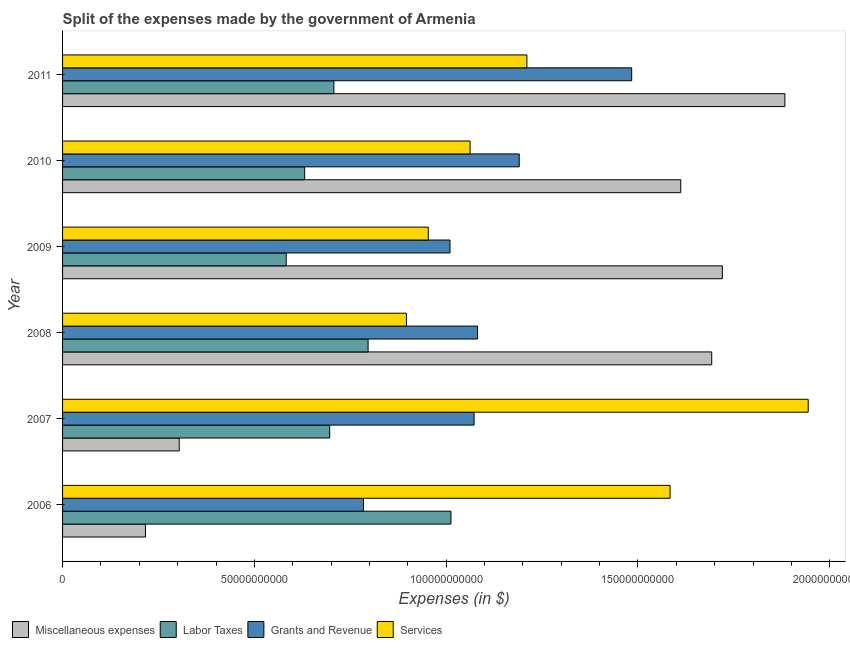Are the number of bars per tick equal to the number of legend labels?
Your answer should be very brief. Yes. How many bars are there on the 5th tick from the top?
Ensure brevity in your answer.  4. How many bars are there on the 1st tick from the bottom?
Ensure brevity in your answer.  4. In how many cases, is the number of bars for a given year not equal to the number of legend labels?
Make the answer very short. 0. What is the amount spent on labor taxes in 2008?
Your response must be concise. 7.97e+1. Across all years, what is the maximum amount spent on labor taxes?
Keep it short and to the point. 1.01e+11. Across all years, what is the minimum amount spent on labor taxes?
Your answer should be very brief. 5.83e+1. In which year was the amount spent on grants and revenue maximum?
Your response must be concise. 2011. In which year was the amount spent on grants and revenue minimum?
Offer a very short reply. 2006. What is the total amount spent on labor taxes in the graph?
Your answer should be compact. 4.43e+11. What is the difference between the amount spent on labor taxes in 2006 and that in 2009?
Ensure brevity in your answer.  4.30e+1. What is the difference between the amount spent on services in 2007 and the amount spent on grants and revenue in 2008?
Make the answer very short. 8.62e+1. What is the average amount spent on grants and revenue per year?
Provide a succinct answer. 1.10e+11. In the year 2007, what is the difference between the amount spent on labor taxes and amount spent on services?
Provide a short and direct response. -1.25e+11. In how many years, is the amount spent on labor taxes greater than 170000000000 $?
Give a very brief answer. 0. What is the ratio of the amount spent on grants and revenue in 2008 to that in 2009?
Keep it short and to the point. 1.07. What is the difference between the highest and the second highest amount spent on services?
Your answer should be very brief. 3.60e+1. What is the difference between the highest and the lowest amount spent on miscellaneous expenses?
Your answer should be very brief. 1.67e+11. In how many years, is the amount spent on labor taxes greater than the average amount spent on labor taxes taken over all years?
Give a very brief answer. 2. Is the sum of the amount spent on miscellaneous expenses in 2007 and 2010 greater than the maximum amount spent on labor taxes across all years?
Your answer should be compact. Yes. What does the 2nd bar from the top in 2007 represents?
Make the answer very short. Grants and Revenue. What does the 4th bar from the bottom in 2007 represents?
Keep it short and to the point. Services. Is it the case that in every year, the sum of the amount spent on miscellaneous expenses and amount spent on labor taxes is greater than the amount spent on grants and revenue?
Offer a very short reply. No. How many bars are there?
Provide a succinct answer. 24. Are all the bars in the graph horizontal?
Make the answer very short. Yes. How many years are there in the graph?
Your answer should be compact. 6. What is the difference between two consecutive major ticks on the X-axis?
Ensure brevity in your answer.  5.00e+1. Are the values on the major ticks of X-axis written in scientific E-notation?
Your answer should be very brief. No. Does the graph contain any zero values?
Your response must be concise. No. Does the graph contain grids?
Provide a short and direct response. No. Where does the legend appear in the graph?
Your response must be concise. Bottom left. How many legend labels are there?
Ensure brevity in your answer.  4. How are the legend labels stacked?
Provide a short and direct response. Horizontal. What is the title of the graph?
Keep it short and to the point. Split of the expenses made by the government of Armenia. What is the label or title of the X-axis?
Make the answer very short. Expenses (in $). What is the Expenses (in $) in Miscellaneous expenses in 2006?
Provide a short and direct response. 2.16e+1. What is the Expenses (in $) in Labor Taxes in 2006?
Your answer should be compact. 1.01e+11. What is the Expenses (in $) of Grants and Revenue in 2006?
Your response must be concise. 7.84e+1. What is the Expenses (in $) of Services in 2006?
Offer a terse response. 1.58e+11. What is the Expenses (in $) in Miscellaneous expenses in 2007?
Make the answer very short. 3.04e+1. What is the Expenses (in $) in Labor Taxes in 2007?
Your response must be concise. 6.96e+1. What is the Expenses (in $) of Grants and Revenue in 2007?
Offer a very short reply. 1.07e+11. What is the Expenses (in $) in Services in 2007?
Offer a very short reply. 1.94e+11. What is the Expenses (in $) of Miscellaneous expenses in 2008?
Your response must be concise. 1.69e+11. What is the Expenses (in $) of Labor Taxes in 2008?
Ensure brevity in your answer.  7.97e+1. What is the Expenses (in $) in Grants and Revenue in 2008?
Your answer should be compact. 1.08e+11. What is the Expenses (in $) of Services in 2008?
Provide a short and direct response. 8.96e+1. What is the Expenses (in $) in Miscellaneous expenses in 2009?
Offer a very short reply. 1.72e+11. What is the Expenses (in $) of Labor Taxes in 2009?
Your answer should be compact. 5.83e+1. What is the Expenses (in $) in Grants and Revenue in 2009?
Your answer should be compact. 1.01e+11. What is the Expenses (in $) in Services in 2009?
Give a very brief answer. 9.53e+1. What is the Expenses (in $) of Miscellaneous expenses in 2010?
Offer a terse response. 1.61e+11. What is the Expenses (in $) in Labor Taxes in 2010?
Your answer should be very brief. 6.31e+1. What is the Expenses (in $) of Grants and Revenue in 2010?
Your answer should be compact. 1.19e+11. What is the Expenses (in $) in Services in 2010?
Ensure brevity in your answer.  1.06e+11. What is the Expenses (in $) of Miscellaneous expenses in 2011?
Keep it short and to the point. 1.88e+11. What is the Expenses (in $) in Labor Taxes in 2011?
Your answer should be compact. 7.07e+1. What is the Expenses (in $) of Grants and Revenue in 2011?
Keep it short and to the point. 1.48e+11. What is the Expenses (in $) in Services in 2011?
Make the answer very short. 1.21e+11. Across all years, what is the maximum Expenses (in $) of Miscellaneous expenses?
Offer a very short reply. 1.88e+11. Across all years, what is the maximum Expenses (in $) in Labor Taxes?
Offer a very short reply. 1.01e+11. Across all years, what is the maximum Expenses (in $) of Grants and Revenue?
Provide a short and direct response. 1.48e+11. Across all years, what is the maximum Expenses (in $) in Services?
Give a very brief answer. 1.94e+11. Across all years, what is the minimum Expenses (in $) of Miscellaneous expenses?
Your answer should be very brief. 2.16e+1. Across all years, what is the minimum Expenses (in $) in Labor Taxes?
Ensure brevity in your answer.  5.83e+1. Across all years, what is the minimum Expenses (in $) of Grants and Revenue?
Your response must be concise. 7.84e+1. Across all years, what is the minimum Expenses (in $) of Services?
Offer a terse response. 8.96e+1. What is the total Expenses (in $) in Miscellaneous expenses in the graph?
Your answer should be compact. 7.43e+11. What is the total Expenses (in $) of Labor Taxes in the graph?
Your answer should be compact. 4.43e+11. What is the total Expenses (in $) in Grants and Revenue in the graph?
Give a very brief answer. 6.62e+11. What is the total Expenses (in $) in Services in the graph?
Offer a very short reply. 7.65e+11. What is the difference between the Expenses (in $) of Miscellaneous expenses in 2006 and that in 2007?
Your answer should be very brief. -8.79e+09. What is the difference between the Expenses (in $) in Labor Taxes in 2006 and that in 2007?
Offer a terse response. 3.16e+1. What is the difference between the Expenses (in $) in Grants and Revenue in 2006 and that in 2007?
Ensure brevity in your answer.  -2.89e+1. What is the difference between the Expenses (in $) in Services in 2006 and that in 2007?
Provide a succinct answer. -3.60e+1. What is the difference between the Expenses (in $) of Miscellaneous expenses in 2006 and that in 2008?
Your answer should be very brief. -1.48e+11. What is the difference between the Expenses (in $) of Labor Taxes in 2006 and that in 2008?
Give a very brief answer. 2.16e+1. What is the difference between the Expenses (in $) in Grants and Revenue in 2006 and that in 2008?
Provide a short and direct response. -2.98e+1. What is the difference between the Expenses (in $) in Services in 2006 and that in 2008?
Your response must be concise. 6.87e+1. What is the difference between the Expenses (in $) of Miscellaneous expenses in 2006 and that in 2009?
Your answer should be very brief. -1.50e+11. What is the difference between the Expenses (in $) of Labor Taxes in 2006 and that in 2009?
Your response must be concise. 4.30e+1. What is the difference between the Expenses (in $) of Grants and Revenue in 2006 and that in 2009?
Provide a succinct answer. -2.26e+1. What is the difference between the Expenses (in $) of Services in 2006 and that in 2009?
Make the answer very short. 6.30e+1. What is the difference between the Expenses (in $) in Miscellaneous expenses in 2006 and that in 2010?
Ensure brevity in your answer.  -1.40e+11. What is the difference between the Expenses (in $) in Labor Taxes in 2006 and that in 2010?
Keep it short and to the point. 3.81e+1. What is the difference between the Expenses (in $) of Grants and Revenue in 2006 and that in 2010?
Give a very brief answer. -4.06e+1. What is the difference between the Expenses (in $) in Services in 2006 and that in 2010?
Your answer should be compact. 5.21e+1. What is the difference between the Expenses (in $) of Miscellaneous expenses in 2006 and that in 2011?
Offer a terse response. -1.67e+11. What is the difference between the Expenses (in $) in Labor Taxes in 2006 and that in 2011?
Offer a very short reply. 3.05e+1. What is the difference between the Expenses (in $) of Grants and Revenue in 2006 and that in 2011?
Make the answer very short. -6.99e+1. What is the difference between the Expenses (in $) of Services in 2006 and that in 2011?
Your answer should be very brief. 3.73e+1. What is the difference between the Expenses (in $) of Miscellaneous expenses in 2007 and that in 2008?
Your answer should be very brief. -1.39e+11. What is the difference between the Expenses (in $) in Labor Taxes in 2007 and that in 2008?
Offer a very short reply. -1.00e+1. What is the difference between the Expenses (in $) of Grants and Revenue in 2007 and that in 2008?
Keep it short and to the point. -8.98e+08. What is the difference between the Expenses (in $) of Services in 2007 and that in 2008?
Offer a terse response. 1.05e+11. What is the difference between the Expenses (in $) in Miscellaneous expenses in 2007 and that in 2009?
Make the answer very short. -1.42e+11. What is the difference between the Expenses (in $) of Labor Taxes in 2007 and that in 2009?
Ensure brevity in your answer.  1.13e+1. What is the difference between the Expenses (in $) of Grants and Revenue in 2007 and that in 2009?
Offer a terse response. 6.28e+09. What is the difference between the Expenses (in $) in Services in 2007 and that in 2009?
Offer a very short reply. 9.90e+1. What is the difference between the Expenses (in $) in Miscellaneous expenses in 2007 and that in 2010?
Offer a terse response. -1.31e+11. What is the difference between the Expenses (in $) in Labor Taxes in 2007 and that in 2010?
Offer a terse response. 6.53e+09. What is the difference between the Expenses (in $) of Grants and Revenue in 2007 and that in 2010?
Your answer should be very brief. -1.18e+1. What is the difference between the Expenses (in $) of Services in 2007 and that in 2010?
Keep it short and to the point. 8.82e+1. What is the difference between the Expenses (in $) of Miscellaneous expenses in 2007 and that in 2011?
Give a very brief answer. -1.58e+11. What is the difference between the Expenses (in $) in Labor Taxes in 2007 and that in 2011?
Your answer should be compact. -1.09e+09. What is the difference between the Expenses (in $) of Grants and Revenue in 2007 and that in 2011?
Your answer should be compact. -4.11e+1. What is the difference between the Expenses (in $) of Services in 2007 and that in 2011?
Provide a succinct answer. 7.33e+1. What is the difference between the Expenses (in $) of Miscellaneous expenses in 2008 and that in 2009?
Provide a succinct answer. -2.76e+09. What is the difference between the Expenses (in $) of Labor Taxes in 2008 and that in 2009?
Your answer should be very brief. 2.14e+1. What is the difference between the Expenses (in $) in Grants and Revenue in 2008 and that in 2009?
Offer a very short reply. 7.18e+09. What is the difference between the Expenses (in $) in Services in 2008 and that in 2009?
Make the answer very short. -5.71e+09. What is the difference between the Expenses (in $) of Miscellaneous expenses in 2008 and that in 2010?
Provide a short and direct response. 8.07e+09. What is the difference between the Expenses (in $) of Labor Taxes in 2008 and that in 2010?
Ensure brevity in your answer.  1.65e+1. What is the difference between the Expenses (in $) of Grants and Revenue in 2008 and that in 2010?
Your response must be concise. -1.09e+1. What is the difference between the Expenses (in $) of Services in 2008 and that in 2010?
Provide a succinct answer. -1.66e+1. What is the difference between the Expenses (in $) in Miscellaneous expenses in 2008 and that in 2011?
Ensure brevity in your answer.  -1.91e+1. What is the difference between the Expenses (in $) in Labor Taxes in 2008 and that in 2011?
Provide a short and direct response. 8.92e+09. What is the difference between the Expenses (in $) in Grants and Revenue in 2008 and that in 2011?
Provide a short and direct response. -4.02e+1. What is the difference between the Expenses (in $) of Services in 2008 and that in 2011?
Provide a short and direct response. -3.14e+1. What is the difference between the Expenses (in $) in Miscellaneous expenses in 2009 and that in 2010?
Provide a succinct answer. 1.08e+1. What is the difference between the Expenses (in $) of Labor Taxes in 2009 and that in 2010?
Make the answer very short. -4.82e+09. What is the difference between the Expenses (in $) of Grants and Revenue in 2009 and that in 2010?
Provide a short and direct response. -1.80e+1. What is the difference between the Expenses (in $) in Services in 2009 and that in 2010?
Make the answer very short. -1.09e+1. What is the difference between the Expenses (in $) of Miscellaneous expenses in 2009 and that in 2011?
Give a very brief answer. -1.63e+1. What is the difference between the Expenses (in $) in Labor Taxes in 2009 and that in 2011?
Keep it short and to the point. -1.24e+1. What is the difference between the Expenses (in $) of Grants and Revenue in 2009 and that in 2011?
Provide a succinct answer. -4.74e+1. What is the difference between the Expenses (in $) in Services in 2009 and that in 2011?
Provide a short and direct response. -2.57e+1. What is the difference between the Expenses (in $) in Miscellaneous expenses in 2010 and that in 2011?
Make the answer very short. -2.71e+1. What is the difference between the Expenses (in $) in Labor Taxes in 2010 and that in 2011?
Ensure brevity in your answer.  -7.62e+09. What is the difference between the Expenses (in $) in Grants and Revenue in 2010 and that in 2011?
Keep it short and to the point. -2.93e+1. What is the difference between the Expenses (in $) in Services in 2010 and that in 2011?
Give a very brief answer. -1.48e+1. What is the difference between the Expenses (in $) of Miscellaneous expenses in 2006 and the Expenses (in $) of Labor Taxes in 2007?
Provide a short and direct response. -4.80e+1. What is the difference between the Expenses (in $) of Miscellaneous expenses in 2006 and the Expenses (in $) of Grants and Revenue in 2007?
Make the answer very short. -8.57e+1. What is the difference between the Expenses (in $) of Miscellaneous expenses in 2006 and the Expenses (in $) of Services in 2007?
Keep it short and to the point. -1.73e+11. What is the difference between the Expenses (in $) of Labor Taxes in 2006 and the Expenses (in $) of Grants and Revenue in 2007?
Give a very brief answer. -6.03e+09. What is the difference between the Expenses (in $) in Labor Taxes in 2006 and the Expenses (in $) in Services in 2007?
Your answer should be very brief. -9.31e+1. What is the difference between the Expenses (in $) in Grants and Revenue in 2006 and the Expenses (in $) in Services in 2007?
Offer a very short reply. -1.16e+11. What is the difference between the Expenses (in $) of Miscellaneous expenses in 2006 and the Expenses (in $) of Labor Taxes in 2008?
Offer a terse response. -5.80e+1. What is the difference between the Expenses (in $) of Miscellaneous expenses in 2006 and the Expenses (in $) of Grants and Revenue in 2008?
Ensure brevity in your answer.  -8.66e+1. What is the difference between the Expenses (in $) in Miscellaneous expenses in 2006 and the Expenses (in $) in Services in 2008?
Keep it short and to the point. -6.80e+1. What is the difference between the Expenses (in $) of Labor Taxes in 2006 and the Expenses (in $) of Grants and Revenue in 2008?
Offer a very short reply. -6.93e+09. What is the difference between the Expenses (in $) in Labor Taxes in 2006 and the Expenses (in $) in Services in 2008?
Ensure brevity in your answer.  1.16e+1. What is the difference between the Expenses (in $) of Grants and Revenue in 2006 and the Expenses (in $) of Services in 2008?
Give a very brief answer. -1.12e+1. What is the difference between the Expenses (in $) in Miscellaneous expenses in 2006 and the Expenses (in $) in Labor Taxes in 2009?
Your response must be concise. -3.67e+1. What is the difference between the Expenses (in $) of Miscellaneous expenses in 2006 and the Expenses (in $) of Grants and Revenue in 2009?
Offer a very short reply. -7.94e+1. What is the difference between the Expenses (in $) in Miscellaneous expenses in 2006 and the Expenses (in $) in Services in 2009?
Give a very brief answer. -7.37e+1. What is the difference between the Expenses (in $) of Labor Taxes in 2006 and the Expenses (in $) of Grants and Revenue in 2009?
Ensure brevity in your answer.  2.45e+08. What is the difference between the Expenses (in $) in Labor Taxes in 2006 and the Expenses (in $) in Services in 2009?
Make the answer very short. 5.90e+09. What is the difference between the Expenses (in $) of Grants and Revenue in 2006 and the Expenses (in $) of Services in 2009?
Your response must be concise. -1.69e+1. What is the difference between the Expenses (in $) of Miscellaneous expenses in 2006 and the Expenses (in $) of Labor Taxes in 2010?
Provide a succinct answer. -4.15e+1. What is the difference between the Expenses (in $) in Miscellaneous expenses in 2006 and the Expenses (in $) in Grants and Revenue in 2010?
Give a very brief answer. -9.74e+1. What is the difference between the Expenses (in $) of Miscellaneous expenses in 2006 and the Expenses (in $) of Services in 2010?
Keep it short and to the point. -8.46e+1. What is the difference between the Expenses (in $) in Labor Taxes in 2006 and the Expenses (in $) in Grants and Revenue in 2010?
Your answer should be compact. -1.78e+1. What is the difference between the Expenses (in $) of Labor Taxes in 2006 and the Expenses (in $) of Services in 2010?
Give a very brief answer. -4.99e+09. What is the difference between the Expenses (in $) of Grants and Revenue in 2006 and the Expenses (in $) of Services in 2010?
Your answer should be compact. -2.78e+1. What is the difference between the Expenses (in $) in Miscellaneous expenses in 2006 and the Expenses (in $) in Labor Taxes in 2011?
Make the answer very short. -4.91e+1. What is the difference between the Expenses (in $) of Miscellaneous expenses in 2006 and the Expenses (in $) of Grants and Revenue in 2011?
Your answer should be very brief. -1.27e+11. What is the difference between the Expenses (in $) of Miscellaneous expenses in 2006 and the Expenses (in $) of Services in 2011?
Offer a very short reply. -9.94e+1. What is the difference between the Expenses (in $) in Labor Taxes in 2006 and the Expenses (in $) in Grants and Revenue in 2011?
Give a very brief answer. -4.71e+1. What is the difference between the Expenses (in $) of Labor Taxes in 2006 and the Expenses (in $) of Services in 2011?
Give a very brief answer. -1.98e+1. What is the difference between the Expenses (in $) in Grants and Revenue in 2006 and the Expenses (in $) in Services in 2011?
Ensure brevity in your answer.  -4.26e+1. What is the difference between the Expenses (in $) of Miscellaneous expenses in 2007 and the Expenses (in $) of Labor Taxes in 2008?
Provide a short and direct response. -4.92e+1. What is the difference between the Expenses (in $) in Miscellaneous expenses in 2007 and the Expenses (in $) in Grants and Revenue in 2008?
Your answer should be very brief. -7.78e+1. What is the difference between the Expenses (in $) of Miscellaneous expenses in 2007 and the Expenses (in $) of Services in 2008?
Your answer should be compact. -5.92e+1. What is the difference between the Expenses (in $) in Labor Taxes in 2007 and the Expenses (in $) in Grants and Revenue in 2008?
Your response must be concise. -3.85e+1. What is the difference between the Expenses (in $) in Labor Taxes in 2007 and the Expenses (in $) in Services in 2008?
Your answer should be very brief. -2.00e+1. What is the difference between the Expenses (in $) of Grants and Revenue in 2007 and the Expenses (in $) of Services in 2008?
Make the answer very short. 1.76e+1. What is the difference between the Expenses (in $) of Miscellaneous expenses in 2007 and the Expenses (in $) of Labor Taxes in 2009?
Offer a very short reply. -2.79e+1. What is the difference between the Expenses (in $) of Miscellaneous expenses in 2007 and the Expenses (in $) of Grants and Revenue in 2009?
Offer a terse response. -7.06e+1. What is the difference between the Expenses (in $) in Miscellaneous expenses in 2007 and the Expenses (in $) in Services in 2009?
Provide a succinct answer. -6.49e+1. What is the difference between the Expenses (in $) in Labor Taxes in 2007 and the Expenses (in $) in Grants and Revenue in 2009?
Offer a very short reply. -3.14e+1. What is the difference between the Expenses (in $) in Labor Taxes in 2007 and the Expenses (in $) in Services in 2009?
Offer a terse response. -2.57e+1. What is the difference between the Expenses (in $) of Grants and Revenue in 2007 and the Expenses (in $) of Services in 2009?
Provide a succinct answer. 1.19e+1. What is the difference between the Expenses (in $) of Miscellaneous expenses in 2007 and the Expenses (in $) of Labor Taxes in 2010?
Provide a short and direct response. -3.27e+1. What is the difference between the Expenses (in $) of Miscellaneous expenses in 2007 and the Expenses (in $) of Grants and Revenue in 2010?
Give a very brief answer. -8.87e+1. What is the difference between the Expenses (in $) in Miscellaneous expenses in 2007 and the Expenses (in $) in Services in 2010?
Provide a short and direct response. -7.58e+1. What is the difference between the Expenses (in $) of Labor Taxes in 2007 and the Expenses (in $) of Grants and Revenue in 2010?
Make the answer very short. -4.94e+1. What is the difference between the Expenses (in $) of Labor Taxes in 2007 and the Expenses (in $) of Services in 2010?
Ensure brevity in your answer.  -3.66e+1. What is the difference between the Expenses (in $) in Grants and Revenue in 2007 and the Expenses (in $) in Services in 2010?
Ensure brevity in your answer.  1.05e+09. What is the difference between the Expenses (in $) in Miscellaneous expenses in 2007 and the Expenses (in $) in Labor Taxes in 2011?
Ensure brevity in your answer.  -4.03e+1. What is the difference between the Expenses (in $) in Miscellaneous expenses in 2007 and the Expenses (in $) in Grants and Revenue in 2011?
Your answer should be compact. -1.18e+11. What is the difference between the Expenses (in $) of Miscellaneous expenses in 2007 and the Expenses (in $) of Services in 2011?
Ensure brevity in your answer.  -9.06e+1. What is the difference between the Expenses (in $) of Labor Taxes in 2007 and the Expenses (in $) of Grants and Revenue in 2011?
Give a very brief answer. -7.87e+1. What is the difference between the Expenses (in $) in Labor Taxes in 2007 and the Expenses (in $) in Services in 2011?
Offer a very short reply. -5.14e+1. What is the difference between the Expenses (in $) of Grants and Revenue in 2007 and the Expenses (in $) of Services in 2011?
Provide a short and direct response. -1.38e+1. What is the difference between the Expenses (in $) of Miscellaneous expenses in 2008 and the Expenses (in $) of Labor Taxes in 2009?
Provide a succinct answer. 1.11e+11. What is the difference between the Expenses (in $) in Miscellaneous expenses in 2008 and the Expenses (in $) in Grants and Revenue in 2009?
Keep it short and to the point. 6.82e+1. What is the difference between the Expenses (in $) in Miscellaneous expenses in 2008 and the Expenses (in $) in Services in 2009?
Your answer should be compact. 7.39e+1. What is the difference between the Expenses (in $) in Labor Taxes in 2008 and the Expenses (in $) in Grants and Revenue in 2009?
Offer a terse response. -2.14e+1. What is the difference between the Expenses (in $) of Labor Taxes in 2008 and the Expenses (in $) of Services in 2009?
Keep it short and to the point. -1.57e+1. What is the difference between the Expenses (in $) in Grants and Revenue in 2008 and the Expenses (in $) in Services in 2009?
Your response must be concise. 1.28e+1. What is the difference between the Expenses (in $) in Miscellaneous expenses in 2008 and the Expenses (in $) in Labor Taxes in 2010?
Offer a terse response. 1.06e+11. What is the difference between the Expenses (in $) of Miscellaneous expenses in 2008 and the Expenses (in $) of Grants and Revenue in 2010?
Ensure brevity in your answer.  5.02e+1. What is the difference between the Expenses (in $) of Miscellaneous expenses in 2008 and the Expenses (in $) of Services in 2010?
Provide a short and direct response. 6.30e+1. What is the difference between the Expenses (in $) of Labor Taxes in 2008 and the Expenses (in $) of Grants and Revenue in 2010?
Your answer should be very brief. -3.94e+1. What is the difference between the Expenses (in $) of Labor Taxes in 2008 and the Expenses (in $) of Services in 2010?
Give a very brief answer. -2.66e+1. What is the difference between the Expenses (in $) in Grants and Revenue in 2008 and the Expenses (in $) in Services in 2010?
Your response must be concise. 1.94e+09. What is the difference between the Expenses (in $) in Miscellaneous expenses in 2008 and the Expenses (in $) in Labor Taxes in 2011?
Your answer should be very brief. 9.85e+1. What is the difference between the Expenses (in $) of Miscellaneous expenses in 2008 and the Expenses (in $) of Grants and Revenue in 2011?
Keep it short and to the point. 2.09e+1. What is the difference between the Expenses (in $) of Miscellaneous expenses in 2008 and the Expenses (in $) of Services in 2011?
Offer a very short reply. 4.82e+1. What is the difference between the Expenses (in $) of Labor Taxes in 2008 and the Expenses (in $) of Grants and Revenue in 2011?
Your answer should be very brief. -6.87e+1. What is the difference between the Expenses (in $) in Labor Taxes in 2008 and the Expenses (in $) in Services in 2011?
Your answer should be compact. -4.14e+1. What is the difference between the Expenses (in $) of Grants and Revenue in 2008 and the Expenses (in $) of Services in 2011?
Make the answer very short. -1.29e+1. What is the difference between the Expenses (in $) in Miscellaneous expenses in 2009 and the Expenses (in $) in Labor Taxes in 2010?
Make the answer very short. 1.09e+11. What is the difference between the Expenses (in $) of Miscellaneous expenses in 2009 and the Expenses (in $) of Grants and Revenue in 2010?
Keep it short and to the point. 5.29e+1. What is the difference between the Expenses (in $) in Miscellaneous expenses in 2009 and the Expenses (in $) in Services in 2010?
Provide a short and direct response. 6.58e+1. What is the difference between the Expenses (in $) in Labor Taxes in 2009 and the Expenses (in $) in Grants and Revenue in 2010?
Make the answer very short. -6.08e+1. What is the difference between the Expenses (in $) of Labor Taxes in 2009 and the Expenses (in $) of Services in 2010?
Keep it short and to the point. -4.79e+1. What is the difference between the Expenses (in $) in Grants and Revenue in 2009 and the Expenses (in $) in Services in 2010?
Give a very brief answer. -5.23e+09. What is the difference between the Expenses (in $) in Miscellaneous expenses in 2009 and the Expenses (in $) in Labor Taxes in 2011?
Provide a succinct answer. 1.01e+11. What is the difference between the Expenses (in $) in Miscellaneous expenses in 2009 and the Expenses (in $) in Grants and Revenue in 2011?
Offer a terse response. 2.36e+1. What is the difference between the Expenses (in $) of Miscellaneous expenses in 2009 and the Expenses (in $) of Services in 2011?
Your answer should be compact. 5.09e+1. What is the difference between the Expenses (in $) in Labor Taxes in 2009 and the Expenses (in $) in Grants and Revenue in 2011?
Offer a very short reply. -9.01e+1. What is the difference between the Expenses (in $) of Labor Taxes in 2009 and the Expenses (in $) of Services in 2011?
Your response must be concise. -6.28e+1. What is the difference between the Expenses (in $) in Grants and Revenue in 2009 and the Expenses (in $) in Services in 2011?
Offer a terse response. -2.00e+1. What is the difference between the Expenses (in $) in Miscellaneous expenses in 2010 and the Expenses (in $) in Labor Taxes in 2011?
Keep it short and to the point. 9.04e+1. What is the difference between the Expenses (in $) of Miscellaneous expenses in 2010 and the Expenses (in $) of Grants and Revenue in 2011?
Your answer should be very brief. 1.28e+1. What is the difference between the Expenses (in $) in Miscellaneous expenses in 2010 and the Expenses (in $) in Services in 2011?
Give a very brief answer. 4.01e+1. What is the difference between the Expenses (in $) of Labor Taxes in 2010 and the Expenses (in $) of Grants and Revenue in 2011?
Provide a short and direct response. -8.53e+1. What is the difference between the Expenses (in $) of Labor Taxes in 2010 and the Expenses (in $) of Services in 2011?
Provide a succinct answer. -5.79e+1. What is the difference between the Expenses (in $) in Grants and Revenue in 2010 and the Expenses (in $) in Services in 2011?
Your answer should be very brief. -2.00e+09. What is the average Expenses (in $) in Miscellaneous expenses per year?
Offer a terse response. 1.24e+11. What is the average Expenses (in $) in Labor Taxes per year?
Keep it short and to the point. 7.38e+1. What is the average Expenses (in $) in Grants and Revenue per year?
Provide a short and direct response. 1.10e+11. What is the average Expenses (in $) of Services per year?
Make the answer very short. 1.28e+11. In the year 2006, what is the difference between the Expenses (in $) in Miscellaneous expenses and Expenses (in $) in Labor Taxes?
Provide a succinct answer. -7.96e+1. In the year 2006, what is the difference between the Expenses (in $) in Miscellaneous expenses and Expenses (in $) in Grants and Revenue?
Keep it short and to the point. -5.68e+1. In the year 2006, what is the difference between the Expenses (in $) of Miscellaneous expenses and Expenses (in $) of Services?
Offer a very short reply. -1.37e+11. In the year 2006, what is the difference between the Expenses (in $) of Labor Taxes and Expenses (in $) of Grants and Revenue?
Keep it short and to the point. 2.28e+1. In the year 2006, what is the difference between the Expenses (in $) in Labor Taxes and Expenses (in $) in Services?
Offer a very short reply. -5.71e+1. In the year 2006, what is the difference between the Expenses (in $) of Grants and Revenue and Expenses (in $) of Services?
Make the answer very short. -8.00e+1. In the year 2007, what is the difference between the Expenses (in $) of Miscellaneous expenses and Expenses (in $) of Labor Taxes?
Offer a terse response. -3.92e+1. In the year 2007, what is the difference between the Expenses (in $) in Miscellaneous expenses and Expenses (in $) in Grants and Revenue?
Offer a very short reply. -7.69e+1. In the year 2007, what is the difference between the Expenses (in $) in Miscellaneous expenses and Expenses (in $) in Services?
Your answer should be very brief. -1.64e+11. In the year 2007, what is the difference between the Expenses (in $) of Labor Taxes and Expenses (in $) of Grants and Revenue?
Make the answer very short. -3.76e+1. In the year 2007, what is the difference between the Expenses (in $) in Labor Taxes and Expenses (in $) in Services?
Provide a short and direct response. -1.25e+11. In the year 2007, what is the difference between the Expenses (in $) in Grants and Revenue and Expenses (in $) in Services?
Give a very brief answer. -8.71e+1. In the year 2008, what is the difference between the Expenses (in $) in Miscellaneous expenses and Expenses (in $) in Labor Taxes?
Provide a succinct answer. 8.96e+1. In the year 2008, what is the difference between the Expenses (in $) in Miscellaneous expenses and Expenses (in $) in Grants and Revenue?
Provide a short and direct response. 6.11e+1. In the year 2008, what is the difference between the Expenses (in $) in Miscellaneous expenses and Expenses (in $) in Services?
Offer a terse response. 7.96e+1. In the year 2008, what is the difference between the Expenses (in $) of Labor Taxes and Expenses (in $) of Grants and Revenue?
Your answer should be compact. -2.85e+1. In the year 2008, what is the difference between the Expenses (in $) of Labor Taxes and Expenses (in $) of Services?
Ensure brevity in your answer.  -9.99e+09. In the year 2008, what is the difference between the Expenses (in $) of Grants and Revenue and Expenses (in $) of Services?
Your response must be concise. 1.85e+1. In the year 2009, what is the difference between the Expenses (in $) in Miscellaneous expenses and Expenses (in $) in Labor Taxes?
Offer a very short reply. 1.14e+11. In the year 2009, what is the difference between the Expenses (in $) of Miscellaneous expenses and Expenses (in $) of Grants and Revenue?
Make the answer very short. 7.10e+1. In the year 2009, what is the difference between the Expenses (in $) in Miscellaneous expenses and Expenses (in $) in Services?
Make the answer very short. 7.67e+1. In the year 2009, what is the difference between the Expenses (in $) of Labor Taxes and Expenses (in $) of Grants and Revenue?
Offer a terse response. -4.27e+1. In the year 2009, what is the difference between the Expenses (in $) in Labor Taxes and Expenses (in $) in Services?
Keep it short and to the point. -3.71e+1. In the year 2009, what is the difference between the Expenses (in $) of Grants and Revenue and Expenses (in $) of Services?
Your response must be concise. 5.66e+09. In the year 2010, what is the difference between the Expenses (in $) in Miscellaneous expenses and Expenses (in $) in Labor Taxes?
Your answer should be very brief. 9.81e+1. In the year 2010, what is the difference between the Expenses (in $) of Miscellaneous expenses and Expenses (in $) of Grants and Revenue?
Keep it short and to the point. 4.21e+1. In the year 2010, what is the difference between the Expenses (in $) in Miscellaneous expenses and Expenses (in $) in Services?
Provide a succinct answer. 5.49e+1. In the year 2010, what is the difference between the Expenses (in $) in Labor Taxes and Expenses (in $) in Grants and Revenue?
Ensure brevity in your answer.  -5.59e+1. In the year 2010, what is the difference between the Expenses (in $) of Labor Taxes and Expenses (in $) of Services?
Your response must be concise. -4.31e+1. In the year 2010, what is the difference between the Expenses (in $) of Grants and Revenue and Expenses (in $) of Services?
Give a very brief answer. 1.28e+1. In the year 2011, what is the difference between the Expenses (in $) of Miscellaneous expenses and Expenses (in $) of Labor Taxes?
Keep it short and to the point. 1.18e+11. In the year 2011, what is the difference between the Expenses (in $) in Miscellaneous expenses and Expenses (in $) in Grants and Revenue?
Keep it short and to the point. 3.99e+1. In the year 2011, what is the difference between the Expenses (in $) of Miscellaneous expenses and Expenses (in $) of Services?
Make the answer very short. 6.73e+1. In the year 2011, what is the difference between the Expenses (in $) in Labor Taxes and Expenses (in $) in Grants and Revenue?
Your answer should be compact. -7.76e+1. In the year 2011, what is the difference between the Expenses (in $) of Labor Taxes and Expenses (in $) of Services?
Your answer should be compact. -5.03e+1. In the year 2011, what is the difference between the Expenses (in $) of Grants and Revenue and Expenses (in $) of Services?
Ensure brevity in your answer.  2.73e+1. What is the ratio of the Expenses (in $) of Miscellaneous expenses in 2006 to that in 2007?
Your answer should be compact. 0.71. What is the ratio of the Expenses (in $) in Labor Taxes in 2006 to that in 2007?
Give a very brief answer. 1.45. What is the ratio of the Expenses (in $) in Grants and Revenue in 2006 to that in 2007?
Your answer should be compact. 0.73. What is the ratio of the Expenses (in $) in Services in 2006 to that in 2007?
Your answer should be very brief. 0.81. What is the ratio of the Expenses (in $) in Miscellaneous expenses in 2006 to that in 2008?
Offer a very short reply. 0.13. What is the ratio of the Expenses (in $) in Labor Taxes in 2006 to that in 2008?
Make the answer very short. 1.27. What is the ratio of the Expenses (in $) of Grants and Revenue in 2006 to that in 2008?
Your answer should be very brief. 0.72. What is the ratio of the Expenses (in $) of Services in 2006 to that in 2008?
Your answer should be very brief. 1.77. What is the ratio of the Expenses (in $) of Miscellaneous expenses in 2006 to that in 2009?
Ensure brevity in your answer.  0.13. What is the ratio of the Expenses (in $) in Labor Taxes in 2006 to that in 2009?
Your answer should be very brief. 1.74. What is the ratio of the Expenses (in $) in Grants and Revenue in 2006 to that in 2009?
Offer a very short reply. 0.78. What is the ratio of the Expenses (in $) in Services in 2006 to that in 2009?
Give a very brief answer. 1.66. What is the ratio of the Expenses (in $) of Miscellaneous expenses in 2006 to that in 2010?
Provide a succinct answer. 0.13. What is the ratio of the Expenses (in $) of Labor Taxes in 2006 to that in 2010?
Your response must be concise. 1.6. What is the ratio of the Expenses (in $) of Grants and Revenue in 2006 to that in 2010?
Provide a short and direct response. 0.66. What is the ratio of the Expenses (in $) of Services in 2006 to that in 2010?
Provide a short and direct response. 1.49. What is the ratio of the Expenses (in $) of Miscellaneous expenses in 2006 to that in 2011?
Provide a succinct answer. 0.11. What is the ratio of the Expenses (in $) of Labor Taxes in 2006 to that in 2011?
Give a very brief answer. 1.43. What is the ratio of the Expenses (in $) of Grants and Revenue in 2006 to that in 2011?
Provide a succinct answer. 0.53. What is the ratio of the Expenses (in $) of Services in 2006 to that in 2011?
Make the answer very short. 1.31. What is the ratio of the Expenses (in $) of Miscellaneous expenses in 2007 to that in 2008?
Give a very brief answer. 0.18. What is the ratio of the Expenses (in $) in Labor Taxes in 2007 to that in 2008?
Your response must be concise. 0.87. What is the ratio of the Expenses (in $) of Services in 2007 to that in 2008?
Make the answer very short. 2.17. What is the ratio of the Expenses (in $) of Miscellaneous expenses in 2007 to that in 2009?
Your answer should be very brief. 0.18. What is the ratio of the Expenses (in $) of Labor Taxes in 2007 to that in 2009?
Provide a short and direct response. 1.19. What is the ratio of the Expenses (in $) in Grants and Revenue in 2007 to that in 2009?
Offer a terse response. 1.06. What is the ratio of the Expenses (in $) in Services in 2007 to that in 2009?
Offer a terse response. 2.04. What is the ratio of the Expenses (in $) of Miscellaneous expenses in 2007 to that in 2010?
Keep it short and to the point. 0.19. What is the ratio of the Expenses (in $) in Labor Taxes in 2007 to that in 2010?
Your response must be concise. 1.1. What is the ratio of the Expenses (in $) of Grants and Revenue in 2007 to that in 2010?
Offer a terse response. 0.9. What is the ratio of the Expenses (in $) in Services in 2007 to that in 2010?
Your answer should be very brief. 1.83. What is the ratio of the Expenses (in $) in Miscellaneous expenses in 2007 to that in 2011?
Provide a succinct answer. 0.16. What is the ratio of the Expenses (in $) of Labor Taxes in 2007 to that in 2011?
Provide a succinct answer. 0.98. What is the ratio of the Expenses (in $) in Grants and Revenue in 2007 to that in 2011?
Offer a terse response. 0.72. What is the ratio of the Expenses (in $) in Services in 2007 to that in 2011?
Make the answer very short. 1.61. What is the ratio of the Expenses (in $) in Miscellaneous expenses in 2008 to that in 2009?
Keep it short and to the point. 0.98. What is the ratio of the Expenses (in $) in Labor Taxes in 2008 to that in 2009?
Provide a succinct answer. 1.37. What is the ratio of the Expenses (in $) of Grants and Revenue in 2008 to that in 2009?
Keep it short and to the point. 1.07. What is the ratio of the Expenses (in $) in Services in 2008 to that in 2009?
Ensure brevity in your answer.  0.94. What is the ratio of the Expenses (in $) of Miscellaneous expenses in 2008 to that in 2010?
Ensure brevity in your answer.  1.05. What is the ratio of the Expenses (in $) in Labor Taxes in 2008 to that in 2010?
Ensure brevity in your answer.  1.26. What is the ratio of the Expenses (in $) in Grants and Revenue in 2008 to that in 2010?
Provide a short and direct response. 0.91. What is the ratio of the Expenses (in $) in Services in 2008 to that in 2010?
Make the answer very short. 0.84. What is the ratio of the Expenses (in $) in Miscellaneous expenses in 2008 to that in 2011?
Provide a short and direct response. 0.9. What is the ratio of the Expenses (in $) of Labor Taxes in 2008 to that in 2011?
Give a very brief answer. 1.13. What is the ratio of the Expenses (in $) in Grants and Revenue in 2008 to that in 2011?
Give a very brief answer. 0.73. What is the ratio of the Expenses (in $) of Services in 2008 to that in 2011?
Your answer should be compact. 0.74. What is the ratio of the Expenses (in $) of Miscellaneous expenses in 2009 to that in 2010?
Make the answer very short. 1.07. What is the ratio of the Expenses (in $) in Labor Taxes in 2009 to that in 2010?
Give a very brief answer. 0.92. What is the ratio of the Expenses (in $) of Grants and Revenue in 2009 to that in 2010?
Make the answer very short. 0.85. What is the ratio of the Expenses (in $) of Services in 2009 to that in 2010?
Offer a very short reply. 0.9. What is the ratio of the Expenses (in $) of Miscellaneous expenses in 2009 to that in 2011?
Offer a very short reply. 0.91. What is the ratio of the Expenses (in $) in Labor Taxes in 2009 to that in 2011?
Offer a very short reply. 0.82. What is the ratio of the Expenses (in $) of Grants and Revenue in 2009 to that in 2011?
Provide a succinct answer. 0.68. What is the ratio of the Expenses (in $) in Services in 2009 to that in 2011?
Your answer should be compact. 0.79. What is the ratio of the Expenses (in $) in Miscellaneous expenses in 2010 to that in 2011?
Your answer should be compact. 0.86. What is the ratio of the Expenses (in $) in Labor Taxes in 2010 to that in 2011?
Offer a terse response. 0.89. What is the ratio of the Expenses (in $) in Grants and Revenue in 2010 to that in 2011?
Your response must be concise. 0.8. What is the ratio of the Expenses (in $) in Services in 2010 to that in 2011?
Your response must be concise. 0.88. What is the difference between the highest and the second highest Expenses (in $) of Miscellaneous expenses?
Your response must be concise. 1.63e+1. What is the difference between the highest and the second highest Expenses (in $) in Labor Taxes?
Your response must be concise. 2.16e+1. What is the difference between the highest and the second highest Expenses (in $) of Grants and Revenue?
Offer a very short reply. 2.93e+1. What is the difference between the highest and the second highest Expenses (in $) of Services?
Keep it short and to the point. 3.60e+1. What is the difference between the highest and the lowest Expenses (in $) of Miscellaneous expenses?
Offer a very short reply. 1.67e+11. What is the difference between the highest and the lowest Expenses (in $) in Labor Taxes?
Your response must be concise. 4.30e+1. What is the difference between the highest and the lowest Expenses (in $) of Grants and Revenue?
Offer a very short reply. 6.99e+1. What is the difference between the highest and the lowest Expenses (in $) of Services?
Offer a very short reply. 1.05e+11. 